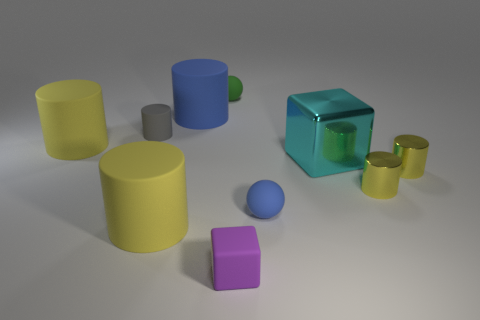What can be inferred about the material of the yellow cylinders compared to the purple cube? The yellow cylinders exhibit a surface texture that suggests a matte finish, absorbing more light and reducing shine, whereas the purple cube displays slightly sharper reflections indicating a smoother, perhaps slightly more reflective finish. 